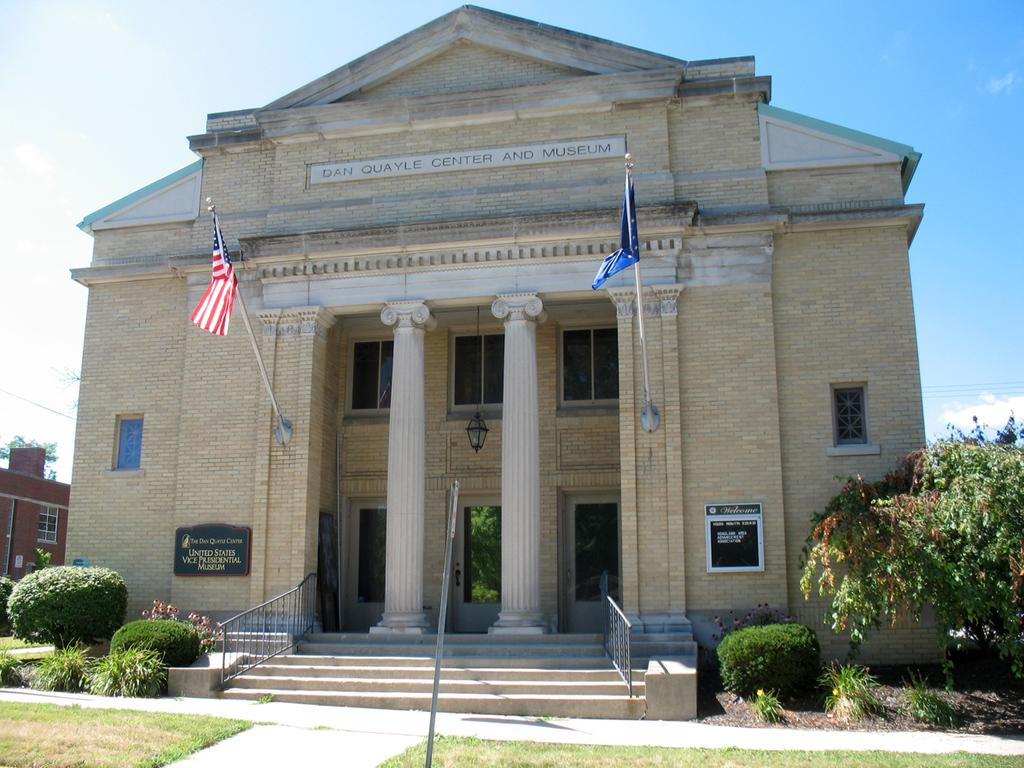What type of outdoor space is shown in the image? There is a lawn in the image. Are there any architectural features present in the image? Yes, there are steps, pillars, and a stone building in the image. What type of vegetation can be seen in the image? Shrubs and trees are visible in the image. What is the color of the sky in the background? The sky is blue in the background. What else can be seen in the sky? Clouds are present in the background. What additional objects are present in the image? There are flags and wires visible in the image. What songs is the father singing while standing on the lawn in the image? There is no father or singing present in the image. 